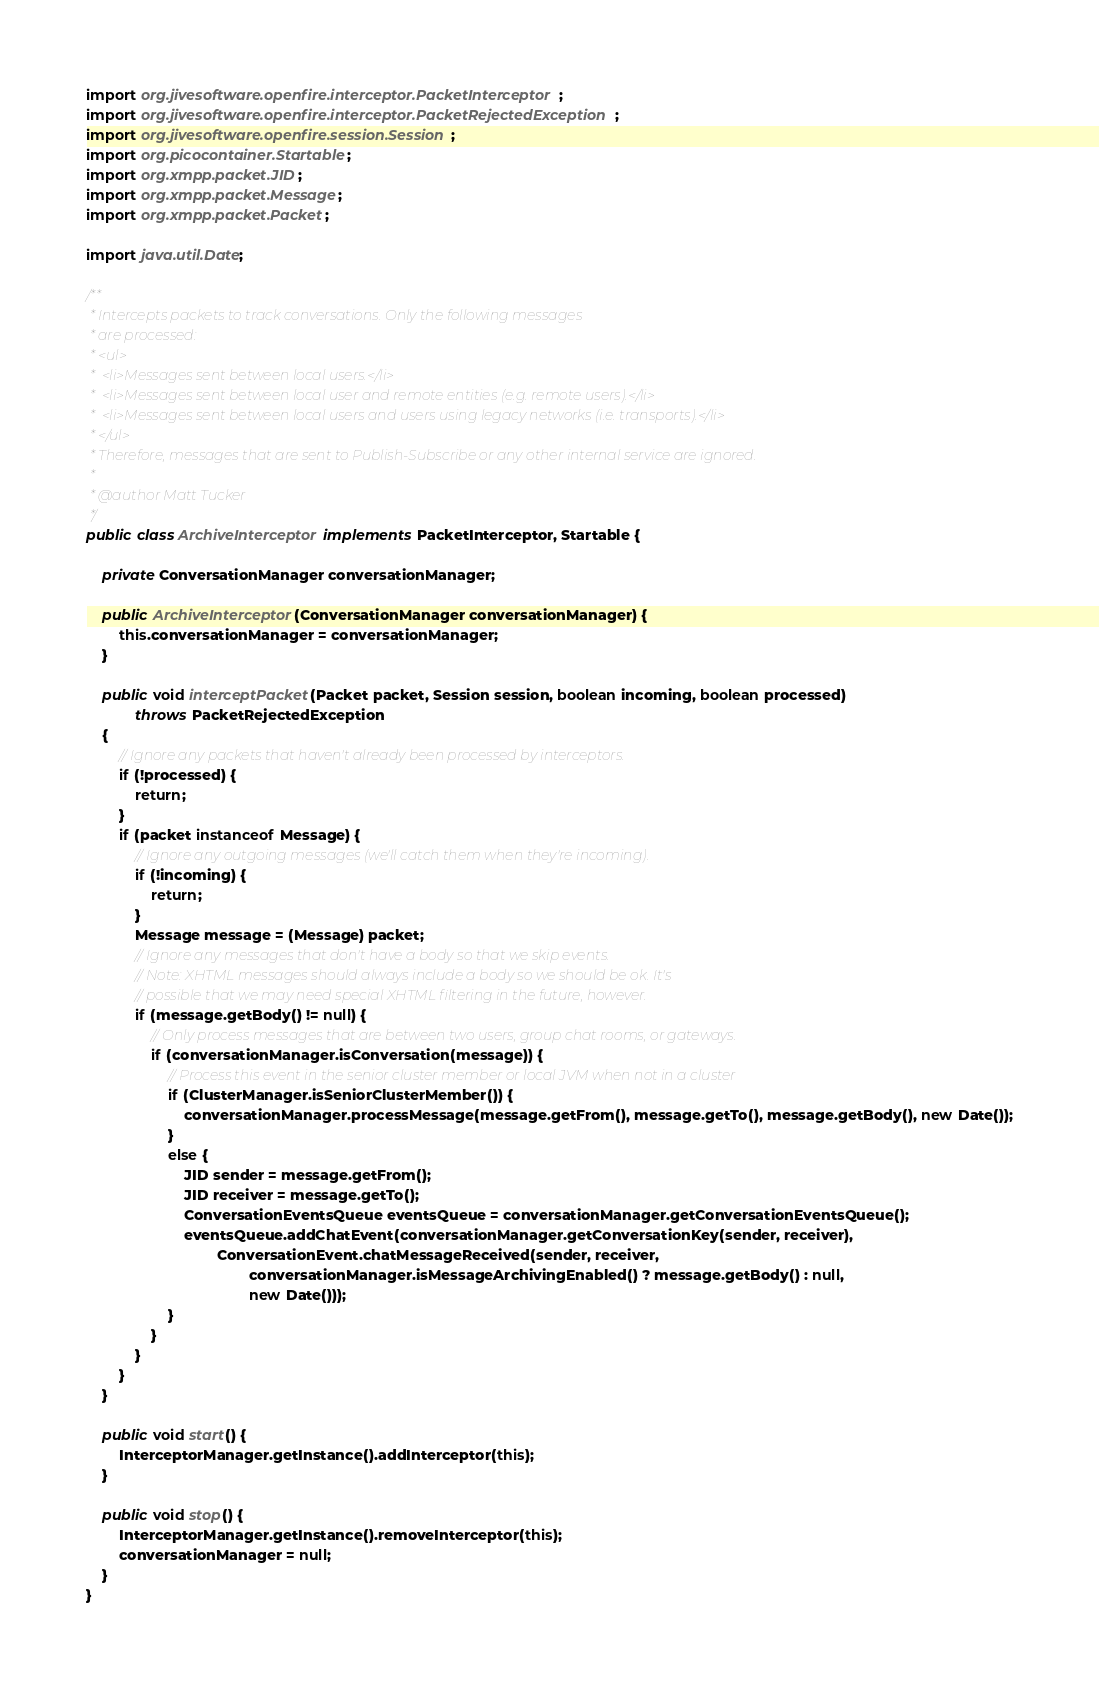<code> <loc_0><loc_0><loc_500><loc_500><_Java_>import org.jivesoftware.openfire.interceptor.PacketInterceptor;
import org.jivesoftware.openfire.interceptor.PacketRejectedException;
import org.jivesoftware.openfire.session.Session;
import org.picocontainer.Startable;
import org.xmpp.packet.JID;
import org.xmpp.packet.Message;
import org.xmpp.packet.Packet;

import java.util.Date;

/**
 * Intercepts packets to track conversations. Only the following messages
 * are processed:
 * <ul>
 *  <li>Messages sent between local users.</li>
 *  <li>Messages sent between local user and remote entities (e.g. remote users).</li>
 *  <li>Messages sent between local users and users using legacy networks (i.e. transports).</li>
 * </ul>
 * Therefore, messages that are sent to Publish-Subscribe or any other internal service are ignored.
 *
 * @author Matt Tucker
 */
public class ArchiveInterceptor implements PacketInterceptor, Startable {

    private ConversationManager conversationManager;

    public ArchiveInterceptor(ConversationManager conversationManager) {
        this.conversationManager = conversationManager;
    }

    public void interceptPacket(Packet packet, Session session, boolean incoming, boolean processed)
            throws PacketRejectedException
    {
        // Ignore any packets that haven't already been processed by interceptors.
        if (!processed) {
            return;
        }
        if (packet instanceof Message) {
            // Ignore any outgoing messages (we'll catch them when they're incoming).
            if (!incoming) {
                return;
            }
            Message message = (Message) packet;
            // Ignore any messages that don't have a body so that we skip events.
            // Note: XHTML messages should always include a body so we should be ok. It's
            // possible that we may need special XHTML filtering in the future, however.
            if (message.getBody() != null) {
                // Only process messages that are between two users, group chat rooms, or gateways.
                if (conversationManager.isConversation(message)) {
                    // Process this event in the senior cluster member or local JVM when not in a cluster
                    if (ClusterManager.isSeniorClusterMember()) {
                        conversationManager.processMessage(message.getFrom(), message.getTo(), message.getBody(), new Date());
                    }
                    else {
                        JID sender = message.getFrom();
                        JID receiver = message.getTo();
                        ConversationEventsQueue eventsQueue = conversationManager.getConversationEventsQueue();
                        eventsQueue.addChatEvent(conversationManager.getConversationKey(sender, receiver),
                                ConversationEvent.chatMessageReceived(sender, receiver,
                                        conversationManager.isMessageArchivingEnabled() ? message.getBody() : null,
                                        new Date()));
                    }
                }
            }
        }
    }

    public void start() {
        InterceptorManager.getInstance().addInterceptor(this);
    }

    public void stop() {
        InterceptorManager.getInstance().removeInterceptor(this);
        conversationManager = null;
    }
}
</code> 